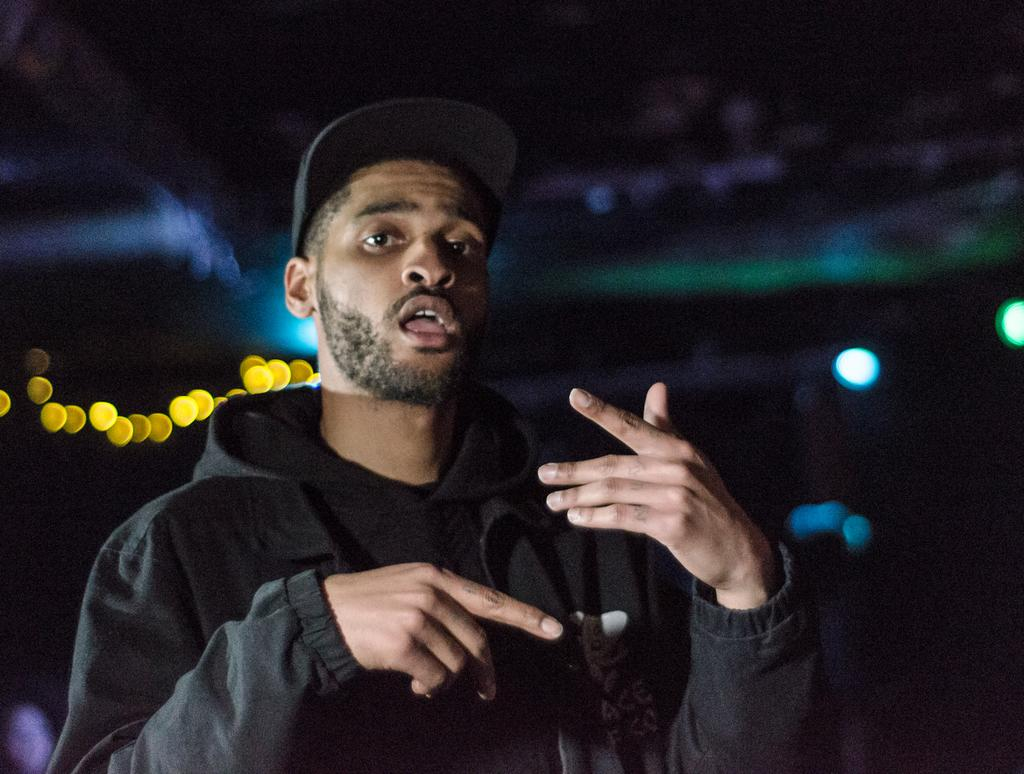What is the main subject of the image? There is a person in the image. What is the person wearing? The person is wearing a black hoodie and a black cap. What can be seen in the background of the image? There are lights and blurry objects in the background of the image. How would you describe the sky in the image? The sky is dark in the image. What type of music can be heard playing in the background of the image? There is no music present in the image; it is a visual representation only. How much sugar is in the person's black hoodie? There is no sugar mentioned or visible in the image, as it is focused on the person's clothing and the background. 